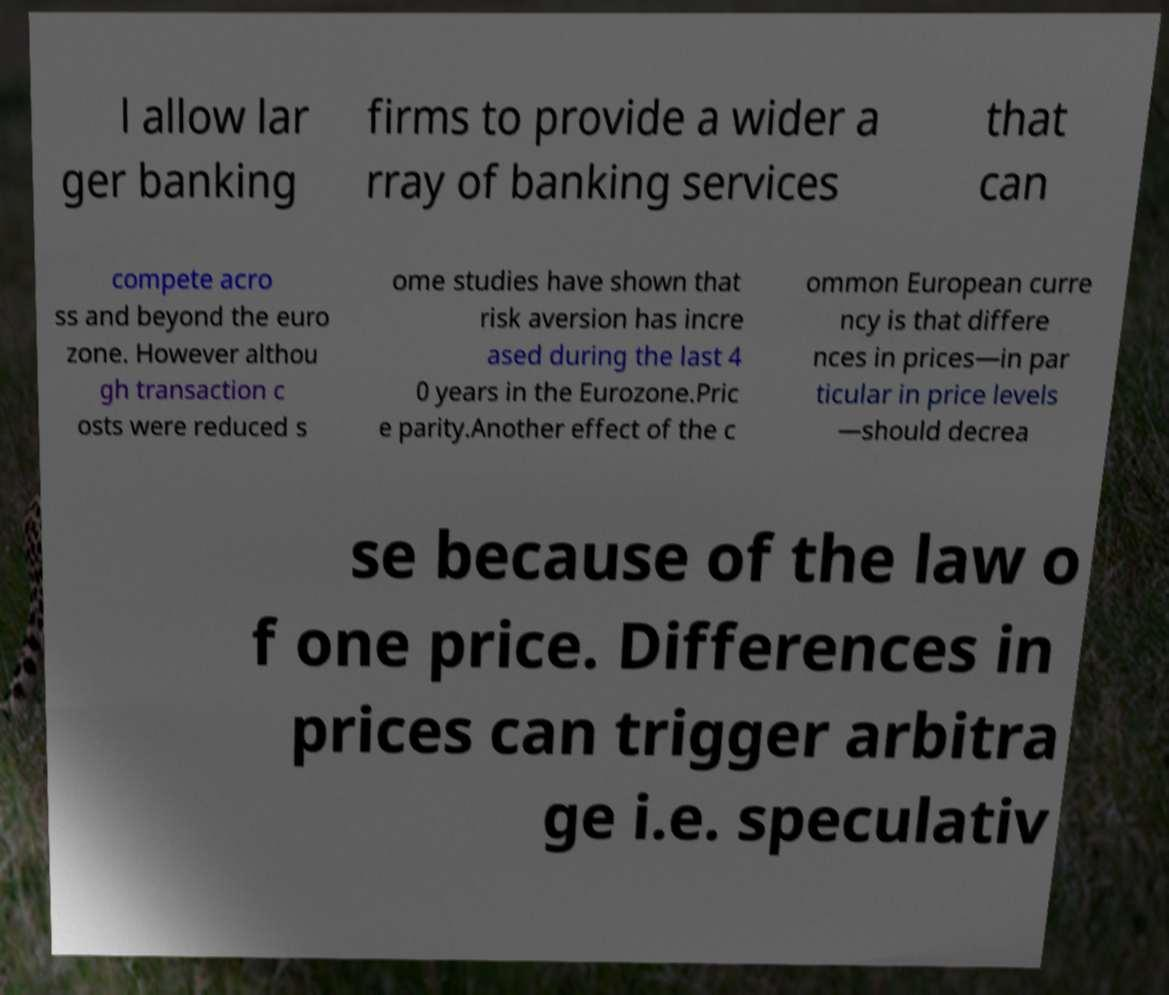Please read and relay the text visible in this image. What does it say? l allow lar ger banking firms to provide a wider a rray of banking services that can compete acro ss and beyond the euro zone. However althou gh transaction c osts were reduced s ome studies have shown that risk aversion has incre ased during the last 4 0 years in the Eurozone.Pric e parity.Another effect of the c ommon European curre ncy is that differe nces in prices—in par ticular in price levels —should decrea se because of the law o f one price. Differences in prices can trigger arbitra ge i.e. speculativ 